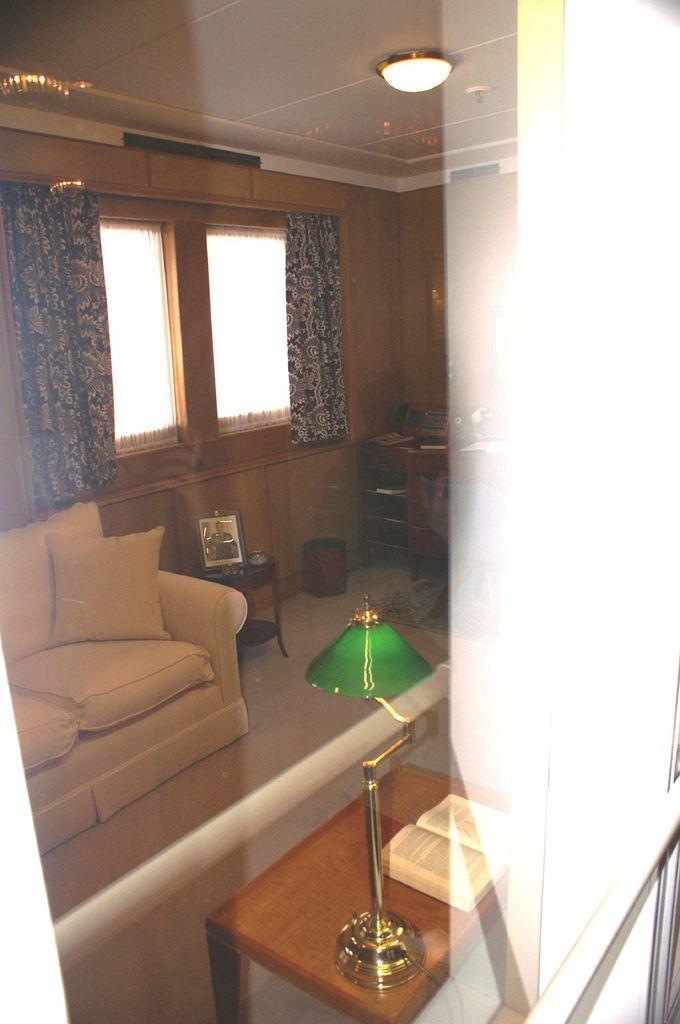In one or two sentences, can you explain what this image depicts? In this picture we can see inside of the house. There is a couch. On the couch we can see pillow. On the background we can see wall,window,curtain. On the top we can see light. This is floor. There is a table. On the table we can see book,lamp. There is stand. On the stand there is a photo frame. 